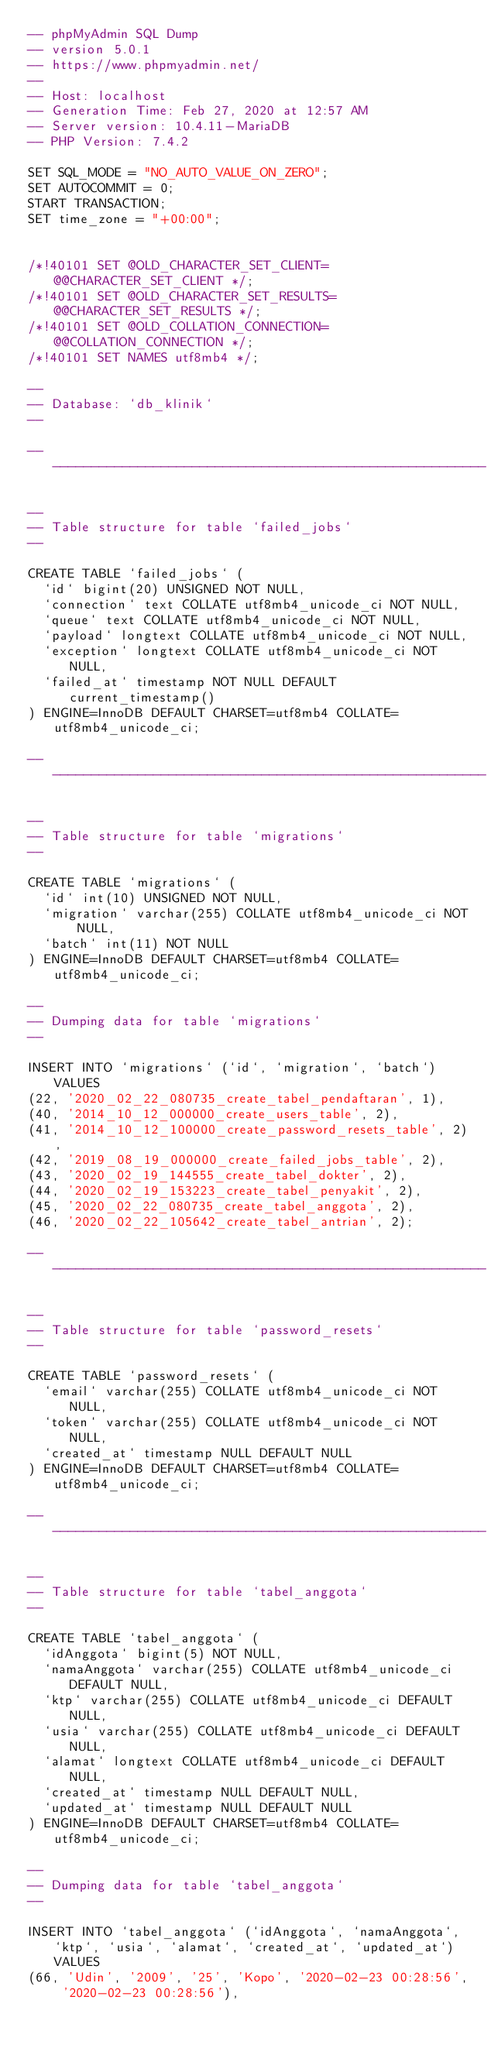Convert code to text. <code><loc_0><loc_0><loc_500><loc_500><_SQL_>-- phpMyAdmin SQL Dump
-- version 5.0.1
-- https://www.phpmyadmin.net/
--
-- Host: localhost
-- Generation Time: Feb 27, 2020 at 12:57 AM
-- Server version: 10.4.11-MariaDB
-- PHP Version: 7.4.2

SET SQL_MODE = "NO_AUTO_VALUE_ON_ZERO";
SET AUTOCOMMIT = 0;
START TRANSACTION;
SET time_zone = "+00:00";


/*!40101 SET @OLD_CHARACTER_SET_CLIENT=@@CHARACTER_SET_CLIENT */;
/*!40101 SET @OLD_CHARACTER_SET_RESULTS=@@CHARACTER_SET_RESULTS */;
/*!40101 SET @OLD_COLLATION_CONNECTION=@@COLLATION_CONNECTION */;
/*!40101 SET NAMES utf8mb4 */;

--
-- Database: `db_klinik`
--

-- --------------------------------------------------------

--
-- Table structure for table `failed_jobs`
--

CREATE TABLE `failed_jobs` (
  `id` bigint(20) UNSIGNED NOT NULL,
  `connection` text COLLATE utf8mb4_unicode_ci NOT NULL,
  `queue` text COLLATE utf8mb4_unicode_ci NOT NULL,
  `payload` longtext COLLATE utf8mb4_unicode_ci NOT NULL,
  `exception` longtext COLLATE utf8mb4_unicode_ci NOT NULL,
  `failed_at` timestamp NOT NULL DEFAULT current_timestamp()
) ENGINE=InnoDB DEFAULT CHARSET=utf8mb4 COLLATE=utf8mb4_unicode_ci;

-- --------------------------------------------------------

--
-- Table structure for table `migrations`
--

CREATE TABLE `migrations` (
  `id` int(10) UNSIGNED NOT NULL,
  `migration` varchar(255) COLLATE utf8mb4_unicode_ci NOT NULL,
  `batch` int(11) NOT NULL
) ENGINE=InnoDB DEFAULT CHARSET=utf8mb4 COLLATE=utf8mb4_unicode_ci;

--
-- Dumping data for table `migrations`
--

INSERT INTO `migrations` (`id`, `migration`, `batch`) VALUES
(22, '2020_02_22_080735_create_tabel_pendaftaran', 1),
(40, '2014_10_12_000000_create_users_table', 2),
(41, '2014_10_12_100000_create_password_resets_table', 2),
(42, '2019_08_19_000000_create_failed_jobs_table', 2),
(43, '2020_02_19_144555_create_tabel_dokter', 2),
(44, '2020_02_19_153223_create_tabel_penyakit', 2),
(45, '2020_02_22_080735_create_tabel_anggota', 2),
(46, '2020_02_22_105642_create_tabel_antrian', 2);

-- --------------------------------------------------------

--
-- Table structure for table `password_resets`
--

CREATE TABLE `password_resets` (
  `email` varchar(255) COLLATE utf8mb4_unicode_ci NOT NULL,
  `token` varchar(255) COLLATE utf8mb4_unicode_ci NOT NULL,
  `created_at` timestamp NULL DEFAULT NULL
) ENGINE=InnoDB DEFAULT CHARSET=utf8mb4 COLLATE=utf8mb4_unicode_ci;

-- --------------------------------------------------------

--
-- Table structure for table `tabel_anggota`
--

CREATE TABLE `tabel_anggota` (
  `idAnggota` bigint(5) NOT NULL,
  `namaAnggota` varchar(255) COLLATE utf8mb4_unicode_ci DEFAULT NULL,
  `ktp` varchar(255) COLLATE utf8mb4_unicode_ci DEFAULT NULL,
  `usia` varchar(255) COLLATE utf8mb4_unicode_ci DEFAULT NULL,
  `alamat` longtext COLLATE utf8mb4_unicode_ci DEFAULT NULL,
  `created_at` timestamp NULL DEFAULT NULL,
  `updated_at` timestamp NULL DEFAULT NULL
) ENGINE=InnoDB DEFAULT CHARSET=utf8mb4 COLLATE=utf8mb4_unicode_ci;

--
-- Dumping data for table `tabel_anggota`
--

INSERT INTO `tabel_anggota` (`idAnggota`, `namaAnggota`, `ktp`, `usia`, `alamat`, `created_at`, `updated_at`) VALUES
(66, 'Udin', '2009', '25', 'Kopo', '2020-02-23 00:28:56', '2020-02-23 00:28:56'),</code> 